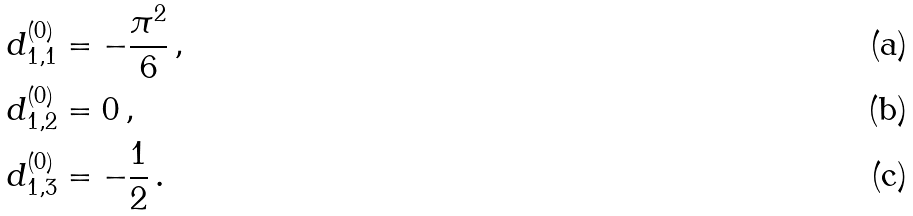Convert formula to latex. <formula><loc_0><loc_0><loc_500><loc_500>d _ { 1 , 1 } ^ { ( 0 ) } & = - \frac { \pi ^ { 2 } } { 6 } \, , \\ d _ { 1 , 2 } ^ { ( 0 ) } & = 0 \, , \\ d _ { 1 , 3 } ^ { ( 0 ) } & = - \frac { 1 } { 2 } \, .</formula> 